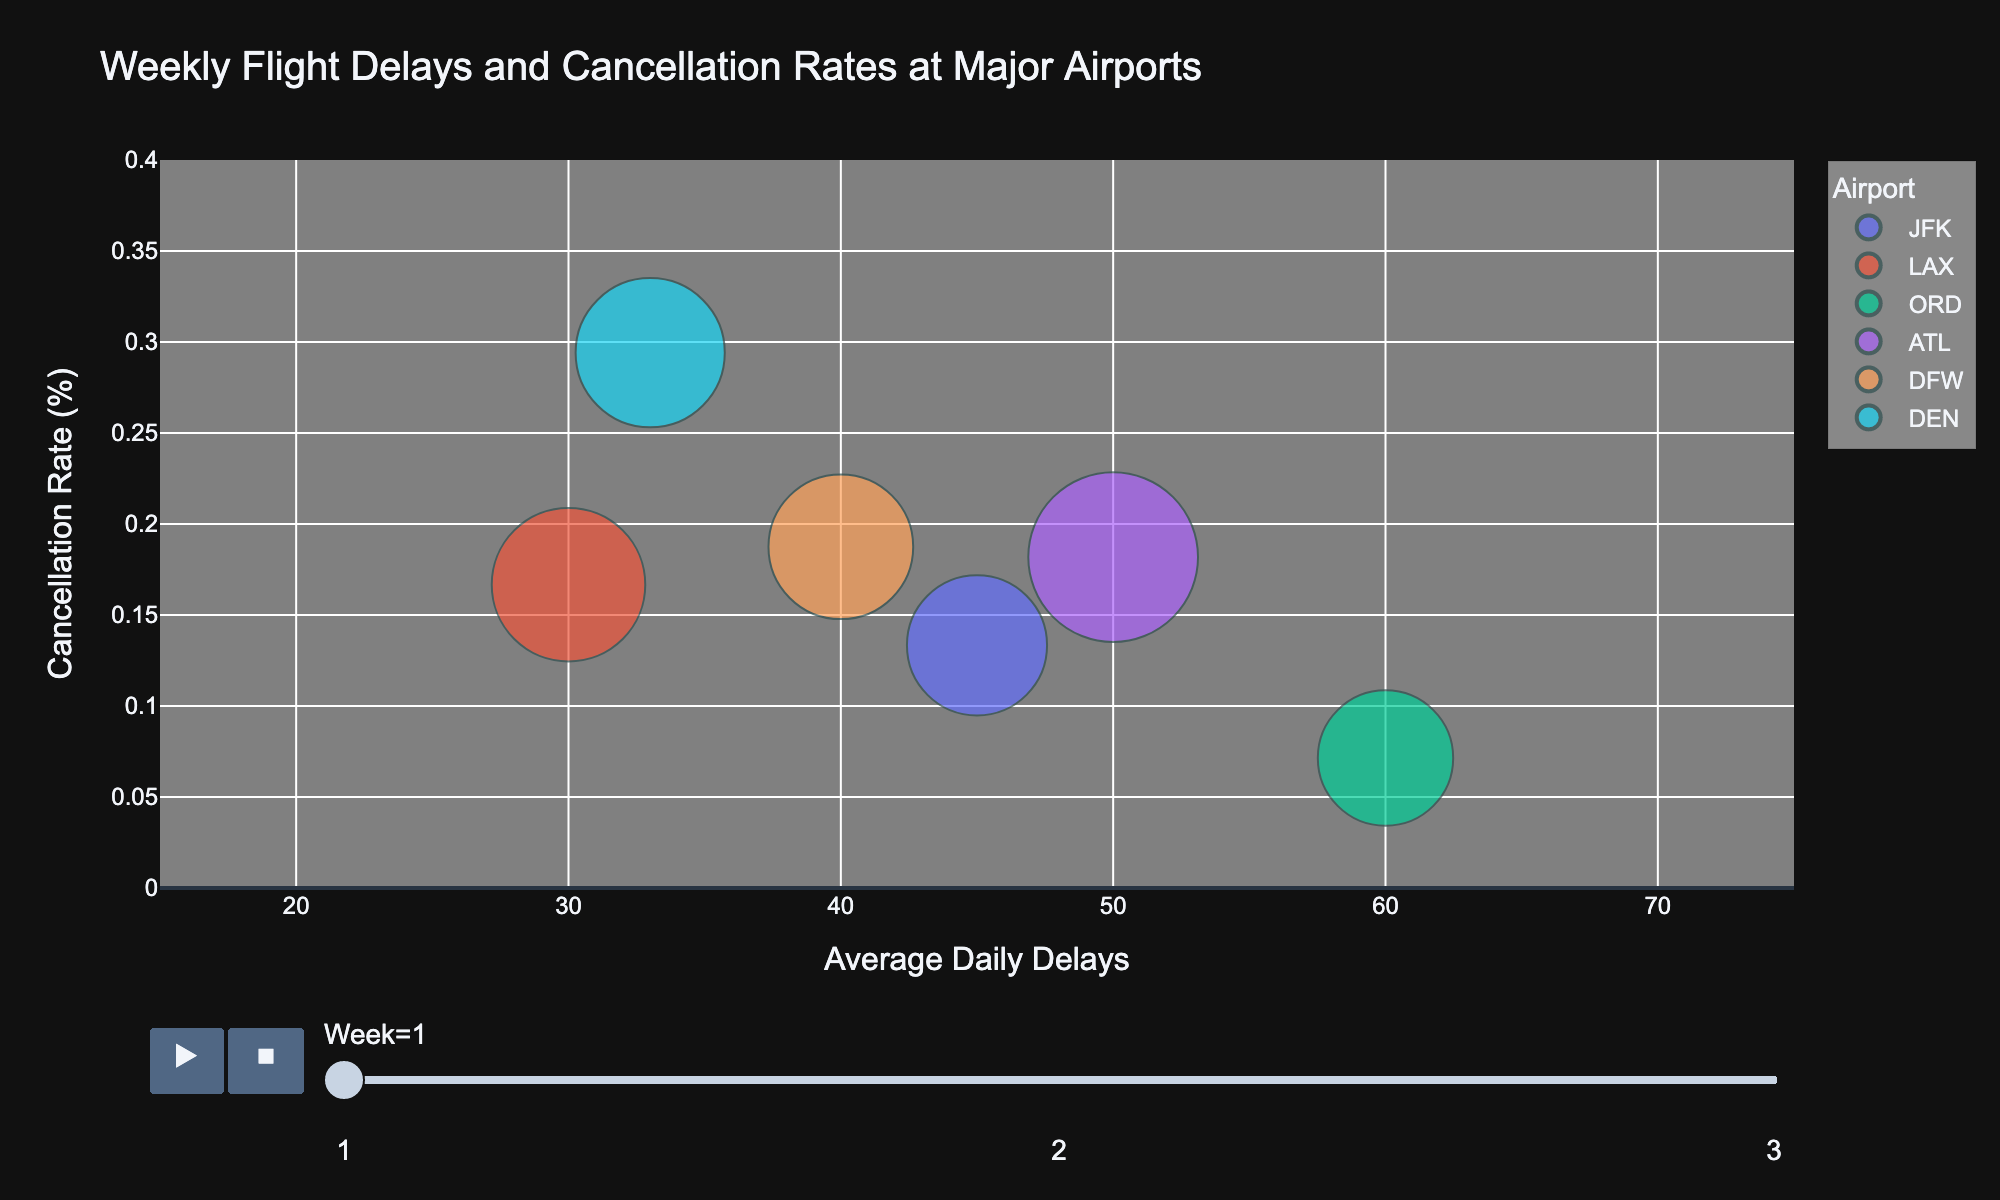What is the title of the chart? The title of the chart is usually prominently displayed at the top of the figure. By reading the title directly from the chart, we can determine what the visualization is about.
Answer: Weekly Flight Delays and Cancellation Rates at Major Airports What does the x-axis represent? The x-axis label is displayed along the horizontal axis of the chart. It tells us what variable the axis represents.
Answer: Average Daily Delays Which airport has the highest number of average daily flights? By looking at the size of the bubbles, the largest bubble indicates the airport with the highest number of average daily flights.
Answer: ATL How does the cancellation rate at JFK change from Week 1 to Week 2? We need to observe the position of the JFK bubble on the y-axis for Week 1 and compare it to its position in Week 2.
Answer: It increases Which week shows the greatest variation in average daily delays among the airports? By comparing the spread of bubbles along the x-axis for different weeks, the week with the most spread out bubbles indicates the greatest variation.
Answer: Week 3 What is the cancellation rate at LAX in Week 3? The y-axis represents the cancellation rate. Find the LAX bubble for Week 3 and read its position on the y-axis.
Answer: Approximately 0.11% Are there any airports with zero cancellations in any week? Look for bubbles that lie exactly on the x-axis (0% on the y-axis) in any animation frame.
Answer: Yes, ORD in Week 3 and DFW in Week 3 In Week 1, which airport has more delays: DEN or DFW? Find the DEN and DFW bubbles in Week 1 and compare their positions on the x-axis, which represents the number of delays.
Answer: DFW Overall, which airport seems to have the most consistent performance in terms of delays and cancellations over all weeks? Evaluate the movement and position of the bubbles for each airport across the weeks. The airport with the least movement and smallest bubbles indicates the most consistent performance.
Answer: LAX 